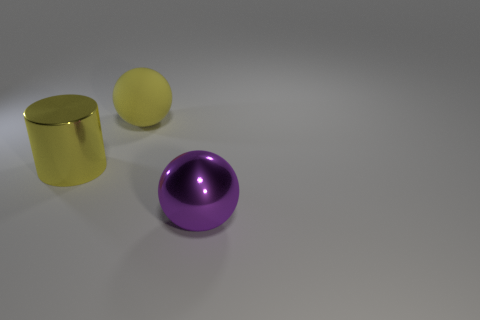Does the large purple thing have the same material as the large ball behind the large yellow cylinder? The large purple object, which appears to be a hemisphere, does not have the same material as the large ball behind the yellow cylinder. While both objects have a reflective sheen, the purple hemisphere has a metallic finish that differs from the more matte and slightly textured finish of the yellow ball. 